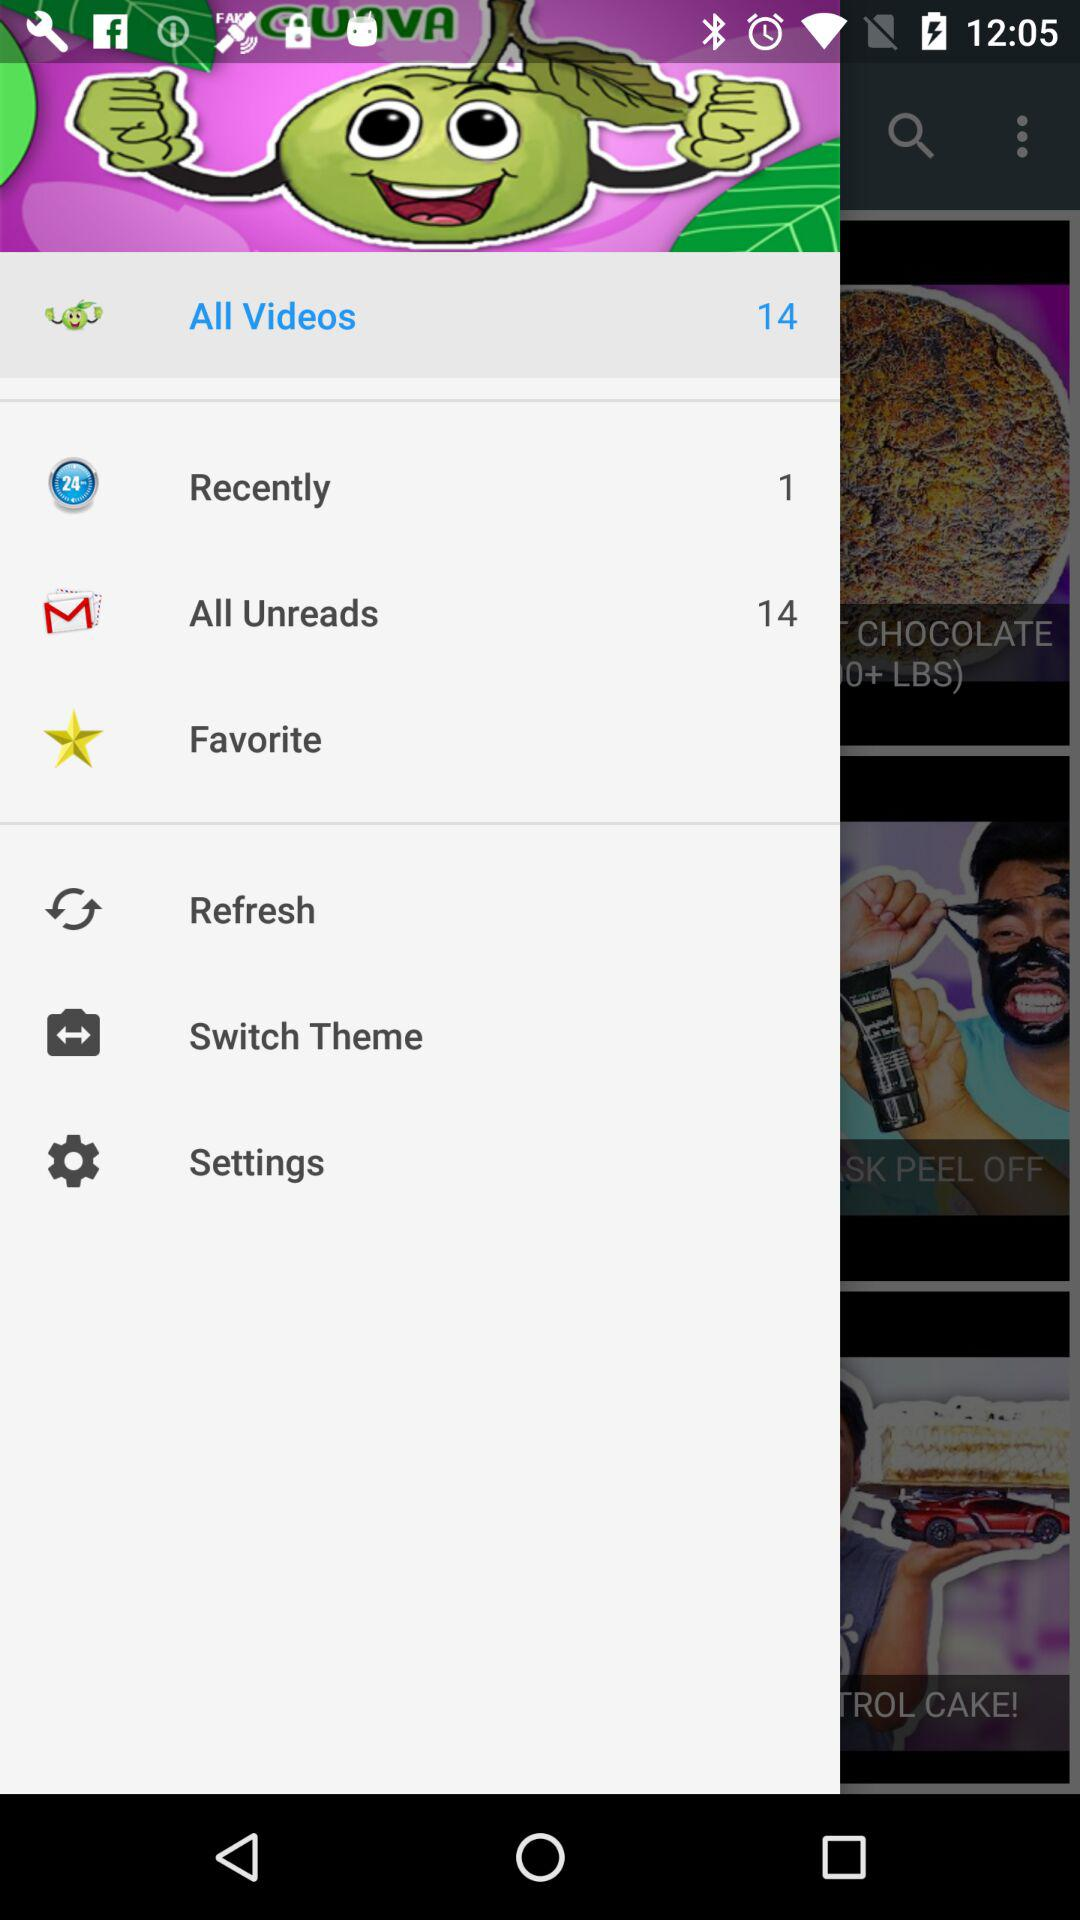How many emails are there in "All Unreads"? There are 14 emails in "All Unreads". 